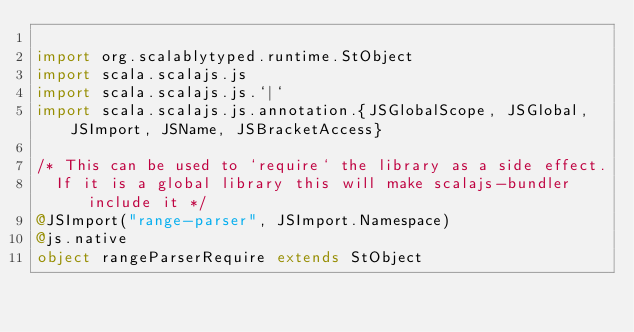<code> <loc_0><loc_0><loc_500><loc_500><_Scala_>
import org.scalablytyped.runtime.StObject
import scala.scalajs.js
import scala.scalajs.js.`|`
import scala.scalajs.js.annotation.{JSGlobalScope, JSGlobal, JSImport, JSName, JSBracketAccess}

/* This can be used to `require` the library as a side effect.
  If it is a global library this will make scalajs-bundler include it */
@JSImport("range-parser", JSImport.Namespace)
@js.native
object rangeParserRequire extends StObject
</code> 